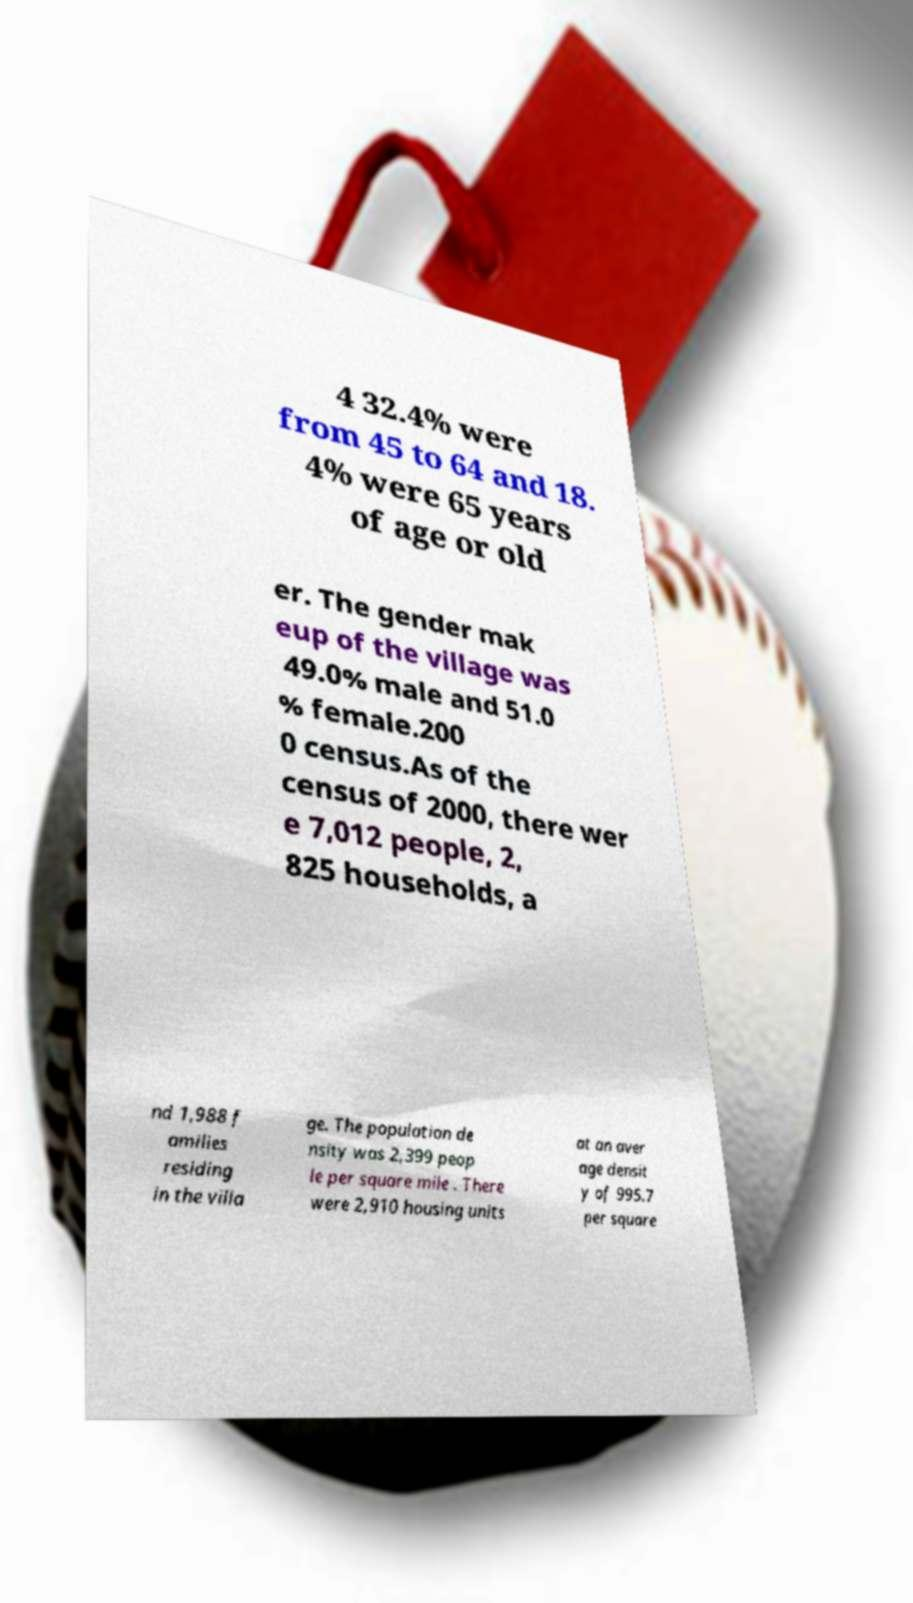What messages or text are displayed in this image? I need them in a readable, typed format. 4 32.4% were from 45 to 64 and 18. 4% were 65 years of age or old er. The gender mak eup of the village was 49.0% male and 51.0 % female.200 0 census.As of the census of 2000, there wer e 7,012 people, 2, 825 households, a nd 1,988 f amilies residing in the villa ge. The population de nsity was 2,399 peop le per square mile . There were 2,910 housing units at an aver age densit y of 995.7 per square 